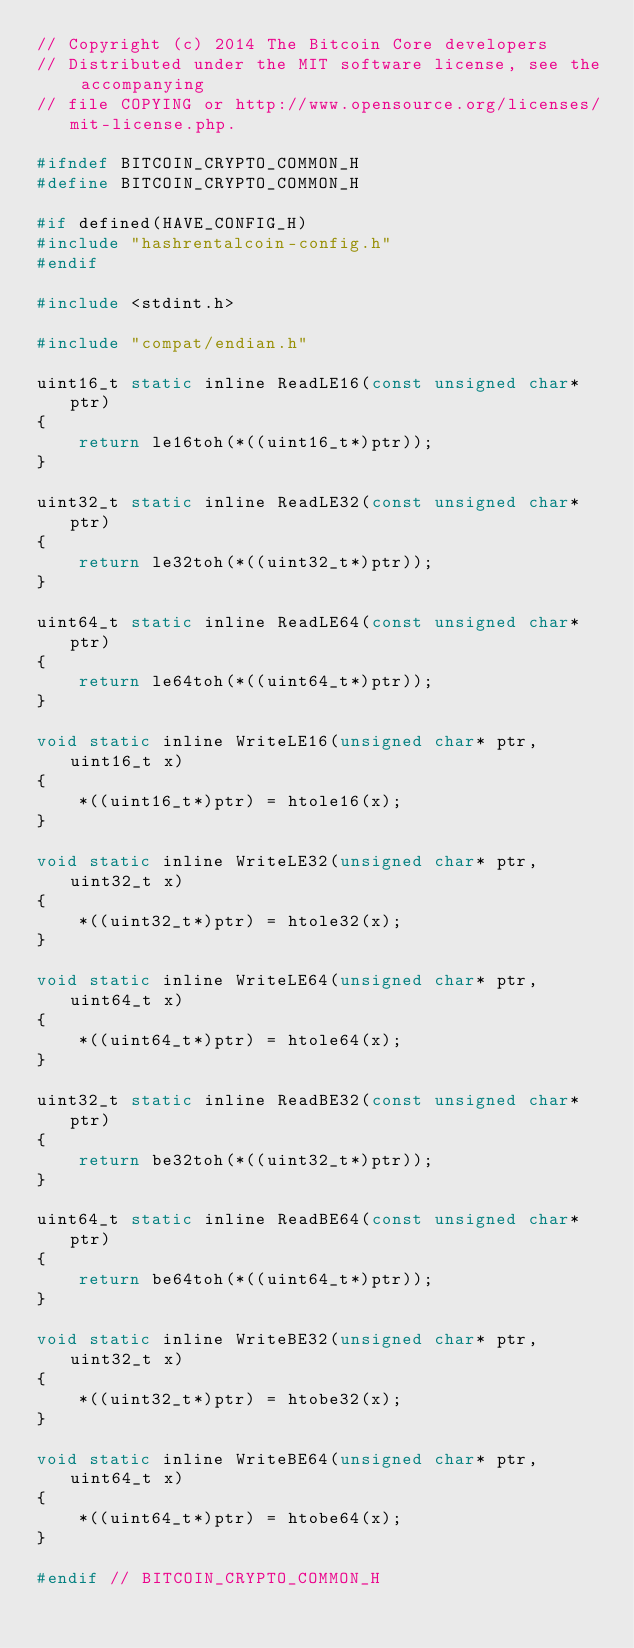Convert code to text. <code><loc_0><loc_0><loc_500><loc_500><_C_>// Copyright (c) 2014 The Bitcoin Core developers
// Distributed under the MIT software license, see the accompanying
// file COPYING or http://www.opensource.org/licenses/mit-license.php.

#ifndef BITCOIN_CRYPTO_COMMON_H
#define BITCOIN_CRYPTO_COMMON_H

#if defined(HAVE_CONFIG_H)
#include "hashrentalcoin-config.h"
#endif

#include <stdint.h>

#include "compat/endian.h"

uint16_t static inline ReadLE16(const unsigned char* ptr)
{
    return le16toh(*((uint16_t*)ptr));
}

uint32_t static inline ReadLE32(const unsigned char* ptr)
{
    return le32toh(*((uint32_t*)ptr));
}

uint64_t static inline ReadLE64(const unsigned char* ptr)
{
    return le64toh(*((uint64_t*)ptr));
}

void static inline WriteLE16(unsigned char* ptr, uint16_t x)
{
    *((uint16_t*)ptr) = htole16(x);
}

void static inline WriteLE32(unsigned char* ptr, uint32_t x)
{
    *((uint32_t*)ptr) = htole32(x);
}

void static inline WriteLE64(unsigned char* ptr, uint64_t x)
{
    *((uint64_t*)ptr) = htole64(x);
}

uint32_t static inline ReadBE32(const unsigned char* ptr)
{
    return be32toh(*((uint32_t*)ptr));
}

uint64_t static inline ReadBE64(const unsigned char* ptr)
{
    return be64toh(*((uint64_t*)ptr));
}

void static inline WriteBE32(unsigned char* ptr, uint32_t x)
{
    *((uint32_t*)ptr) = htobe32(x);
}

void static inline WriteBE64(unsigned char* ptr, uint64_t x)
{
    *((uint64_t*)ptr) = htobe64(x);
}

#endif // BITCOIN_CRYPTO_COMMON_H
</code> 